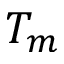<formula> <loc_0><loc_0><loc_500><loc_500>T _ { m }</formula> 